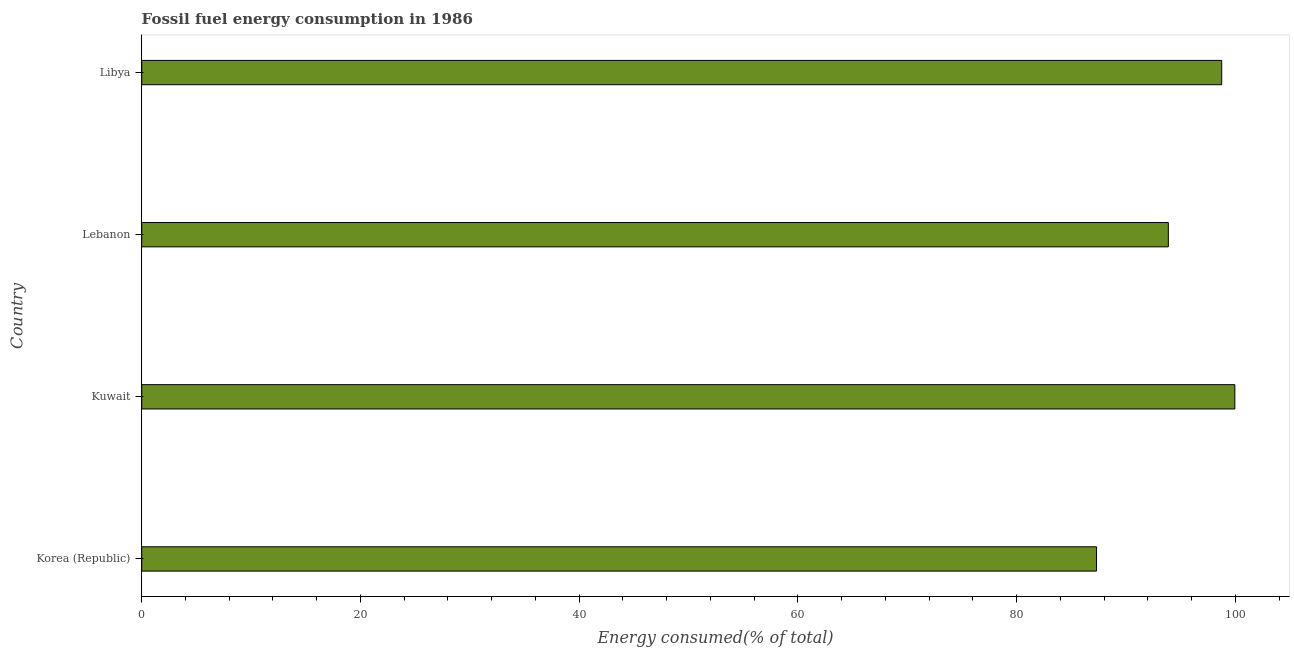Does the graph contain any zero values?
Make the answer very short. No. What is the title of the graph?
Offer a very short reply. Fossil fuel energy consumption in 1986. What is the label or title of the X-axis?
Provide a succinct answer. Energy consumed(% of total). What is the fossil fuel energy consumption in Lebanon?
Provide a short and direct response. 93.88. Across all countries, what is the maximum fossil fuel energy consumption?
Ensure brevity in your answer.  99.96. Across all countries, what is the minimum fossil fuel energy consumption?
Provide a succinct answer. 87.31. In which country was the fossil fuel energy consumption maximum?
Keep it short and to the point. Kuwait. What is the sum of the fossil fuel energy consumption?
Give a very brief answer. 379.92. What is the difference between the fossil fuel energy consumption in Korea (Republic) and Libya?
Provide a succinct answer. -11.45. What is the average fossil fuel energy consumption per country?
Keep it short and to the point. 94.98. What is the median fossil fuel energy consumption?
Give a very brief answer. 96.32. In how many countries, is the fossil fuel energy consumption greater than 20 %?
Make the answer very short. 4. What is the ratio of the fossil fuel energy consumption in Korea (Republic) to that in Libya?
Your answer should be very brief. 0.88. Is the fossil fuel energy consumption in Kuwait less than that in Lebanon?
Offer a very short reply. No. Is the difference between the fossil fuel energy consumption in Kuwait and Libya greater than the difference between any two countries?
Make the answer very short. No. What is the difference between the highest and the second highest fossil fuel energy consumption?
Your answer should be very brief. 1.2. Is the sum of the fossil fuel energy consumption in Korea (Republic) and Libya greater than the maximum fossil fuel energy consumption across all countries?
Make the answer very short. Yes. What is the difference between the highest and the lowest fossil fuel energy consumption?
Offer a very short reply. 12.65. How many countries are there in the graph?
Your response must be concise. 4. What is the difference between two consecutive major ticks on the X-axis?
Your response must be concise. 20. What is the Energy consumed(% of total) of Korea (Republic)?
Your answer should be compact. 87.31. What is the Energy consumed(% of total) in Kuwait?
Your answer should be compact. 99.96. What is the Energy consumed(% of total) in Lebanon?
Your answer should be compact. 93.88. What is the Energy consumed(% of total) of Libya?
Offer a very short reply. 98.76. What is the difference between the Energy consumed(% of total) in Korea (Republic) and Kuwait?
Your response must be concise. -12.65. What is the difference between the Energy consumed(% of total) in Korea (Republic) and Lebanon?
Give a very brief answer. -6.57. What is the difference between the Energy consumed(% of total) in Korea (Republic) and Libya?
Provide a short and direct response. -11.45. What is the difference between the Energy consumed(% of total) in Kuwait and Lebanon?
Provide a short and direct response. 6.08. What is the difference between the Energy consumed(% of total) in Kuwait and Libya?
Ensure brevity in your answer.  1.2. What is the difference between the Energy consumed(% of total) in Lebanon and Libya?
Your answer should be very brief. -4.88. What is the ratio of the Energy consumed(% of total) in Korea (Republic) to that in Kuwait?
Keep it short and to the point. 0.87. What is the ratio of the Energy consumed(% of total) in Korea (Republic) to that in Libya?
Your response must be concise. 0.88. What is the ratio of the Energy consumed(% of total) in Kuwait to that in Lebanon?
Your answer should be very brief. 1.06. What is the ratio of the Energy consumed(% of total) in Lebanon to that in Libya?
Provide a succinct answer. 0.95. 